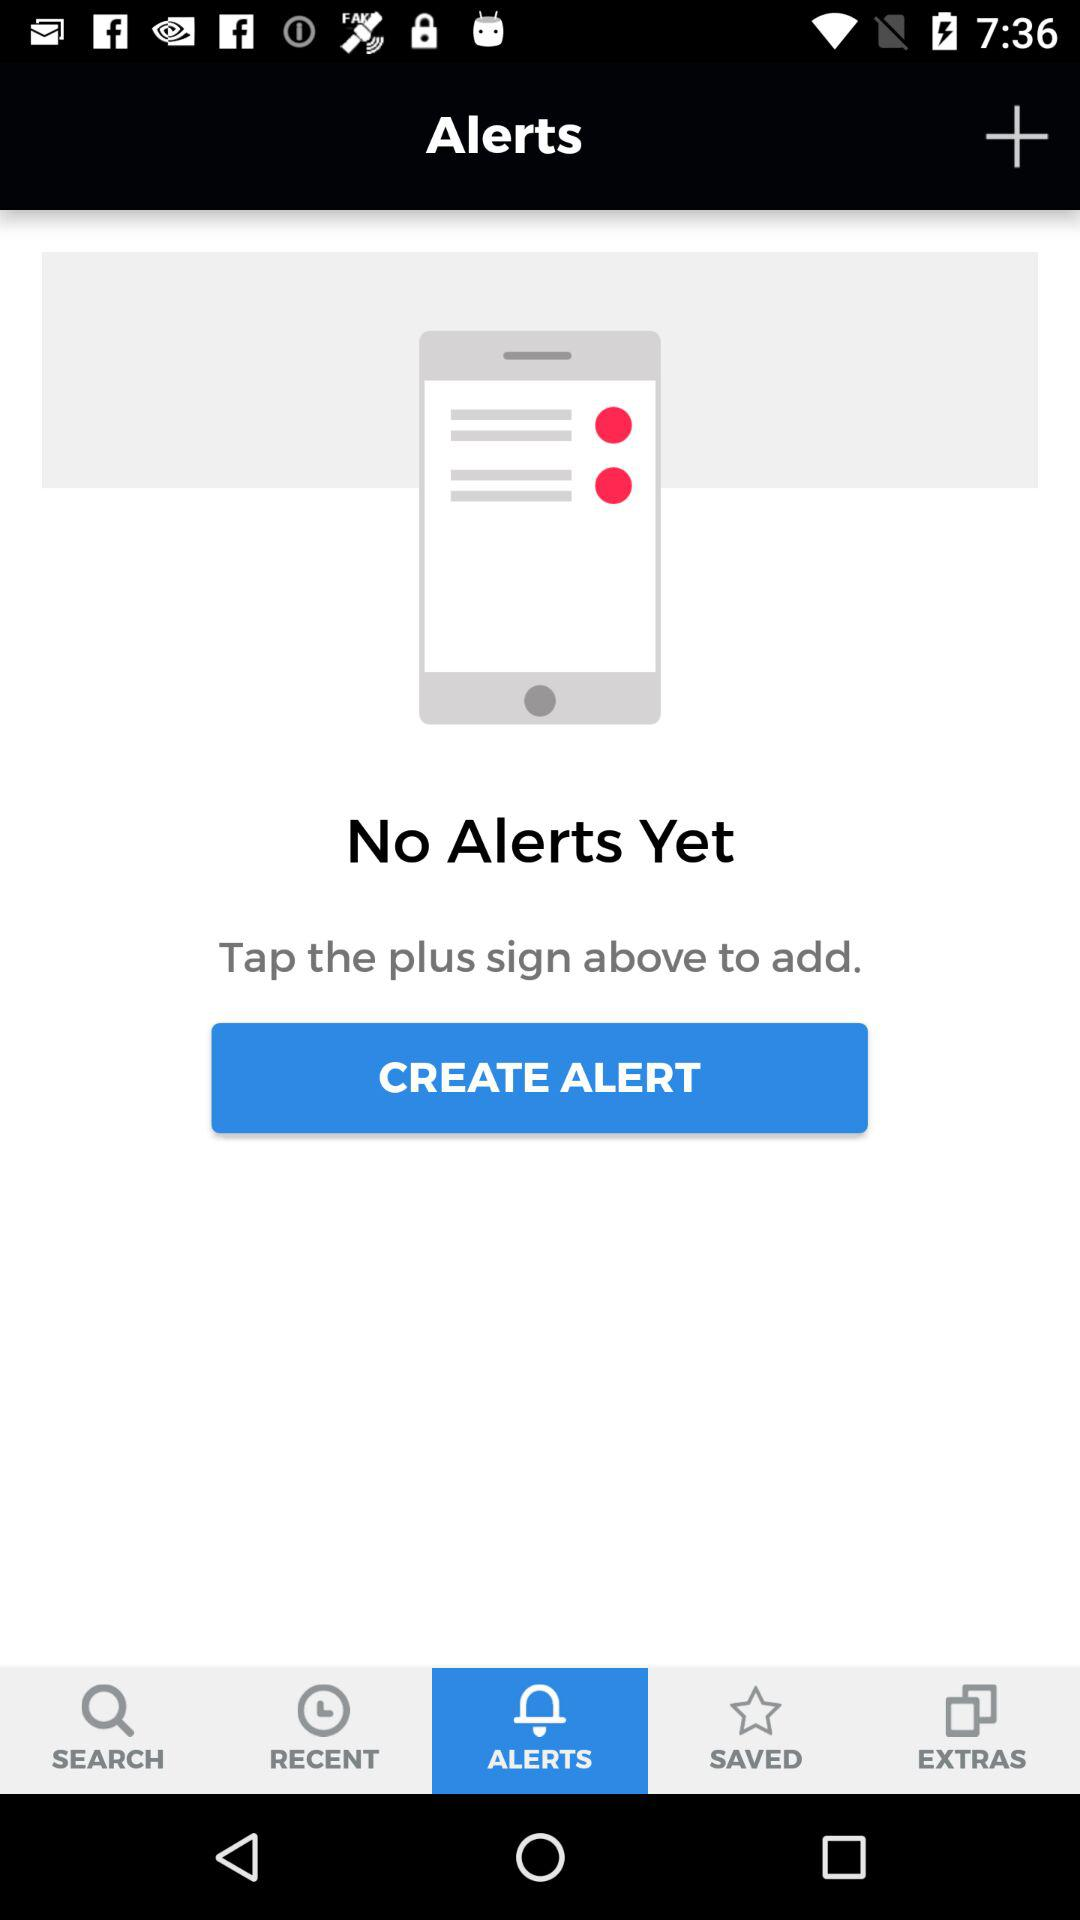Is there any alert? There is no alert. 